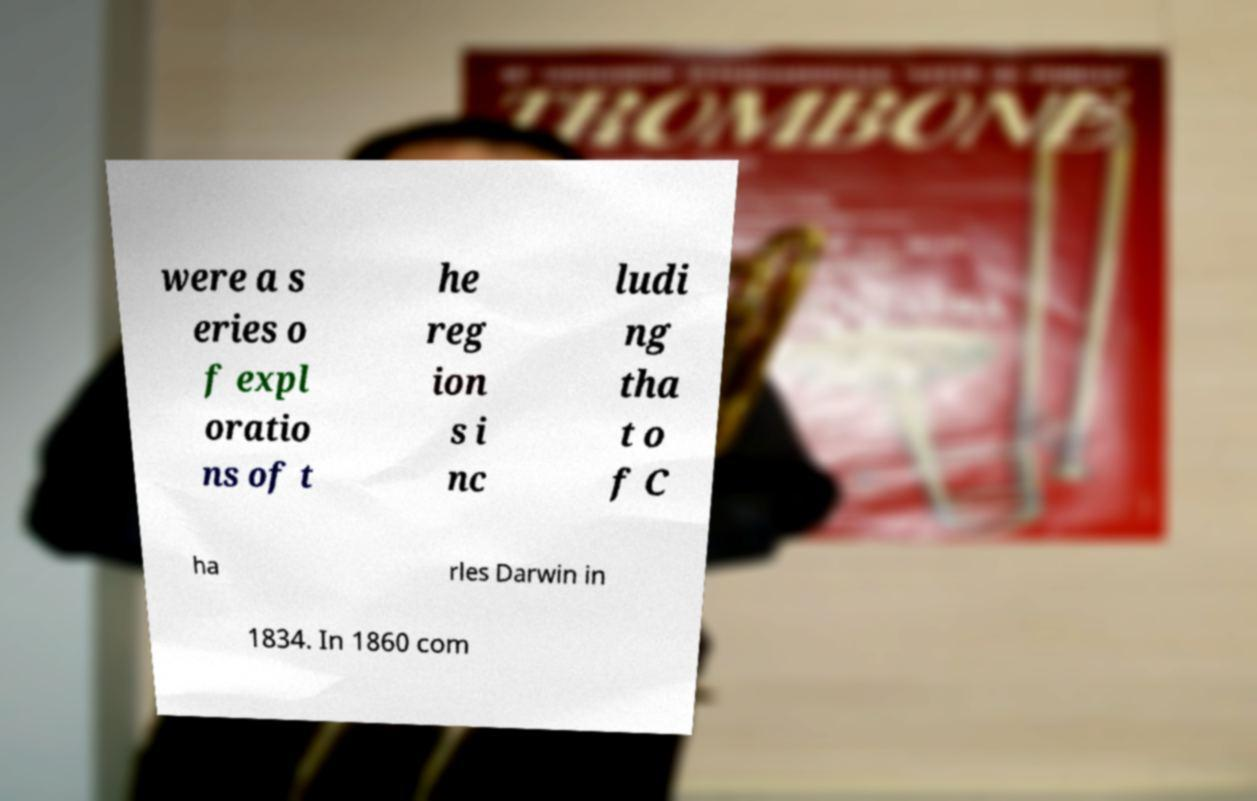I need the written content from this picture converted into text. Can you do that? were a s eries o f expl oratio ns of t he reg ion s i nc ludi ng tha t o f C ha rles Darwin in 1834. In 1860 com 